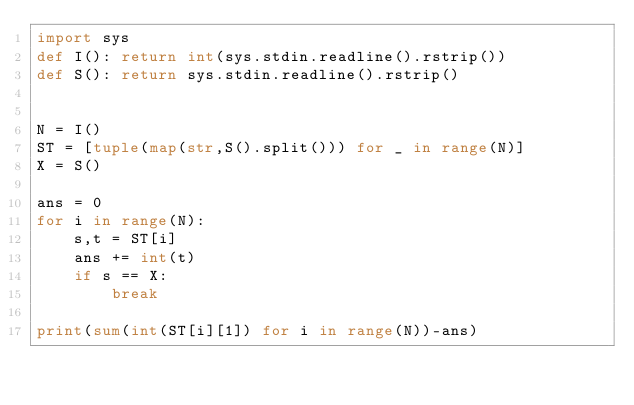Convert code to text. <code><loc_0><loc_0><loc_500><loc_500><_Python_>import sys
def I(): return int(sys.stdin.readline().rstrip())
def S(): return sys.stdin.readline().rstrip()


N = I()
ST = [tuple(map(str,S().split())) for _ in range(N)]
X = S()

ans = 0
for i in range(N):
    s,t = ST[i]
    ans += int(t)
    if s == X:
        break

print(sum(int(ST[i][1]) for i in range(N))-ans)
</code> 